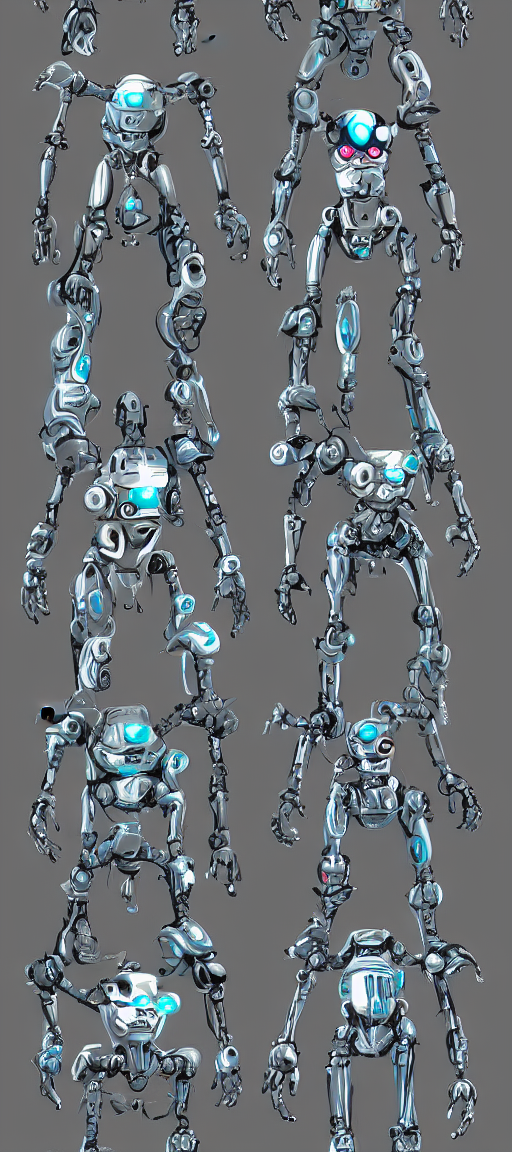What design elements make these robotic figures appear futuristic? The robots in this image are designed with sleek lines, streamlined shapes, and a shiny metallic finish. The use of blue lighting and glowing elements gives them an advanced, high-tech feel characteristic of futuristic design. Articulated joints and visible wiring add to the complexity and believability of their construction as next-generation robotics. 